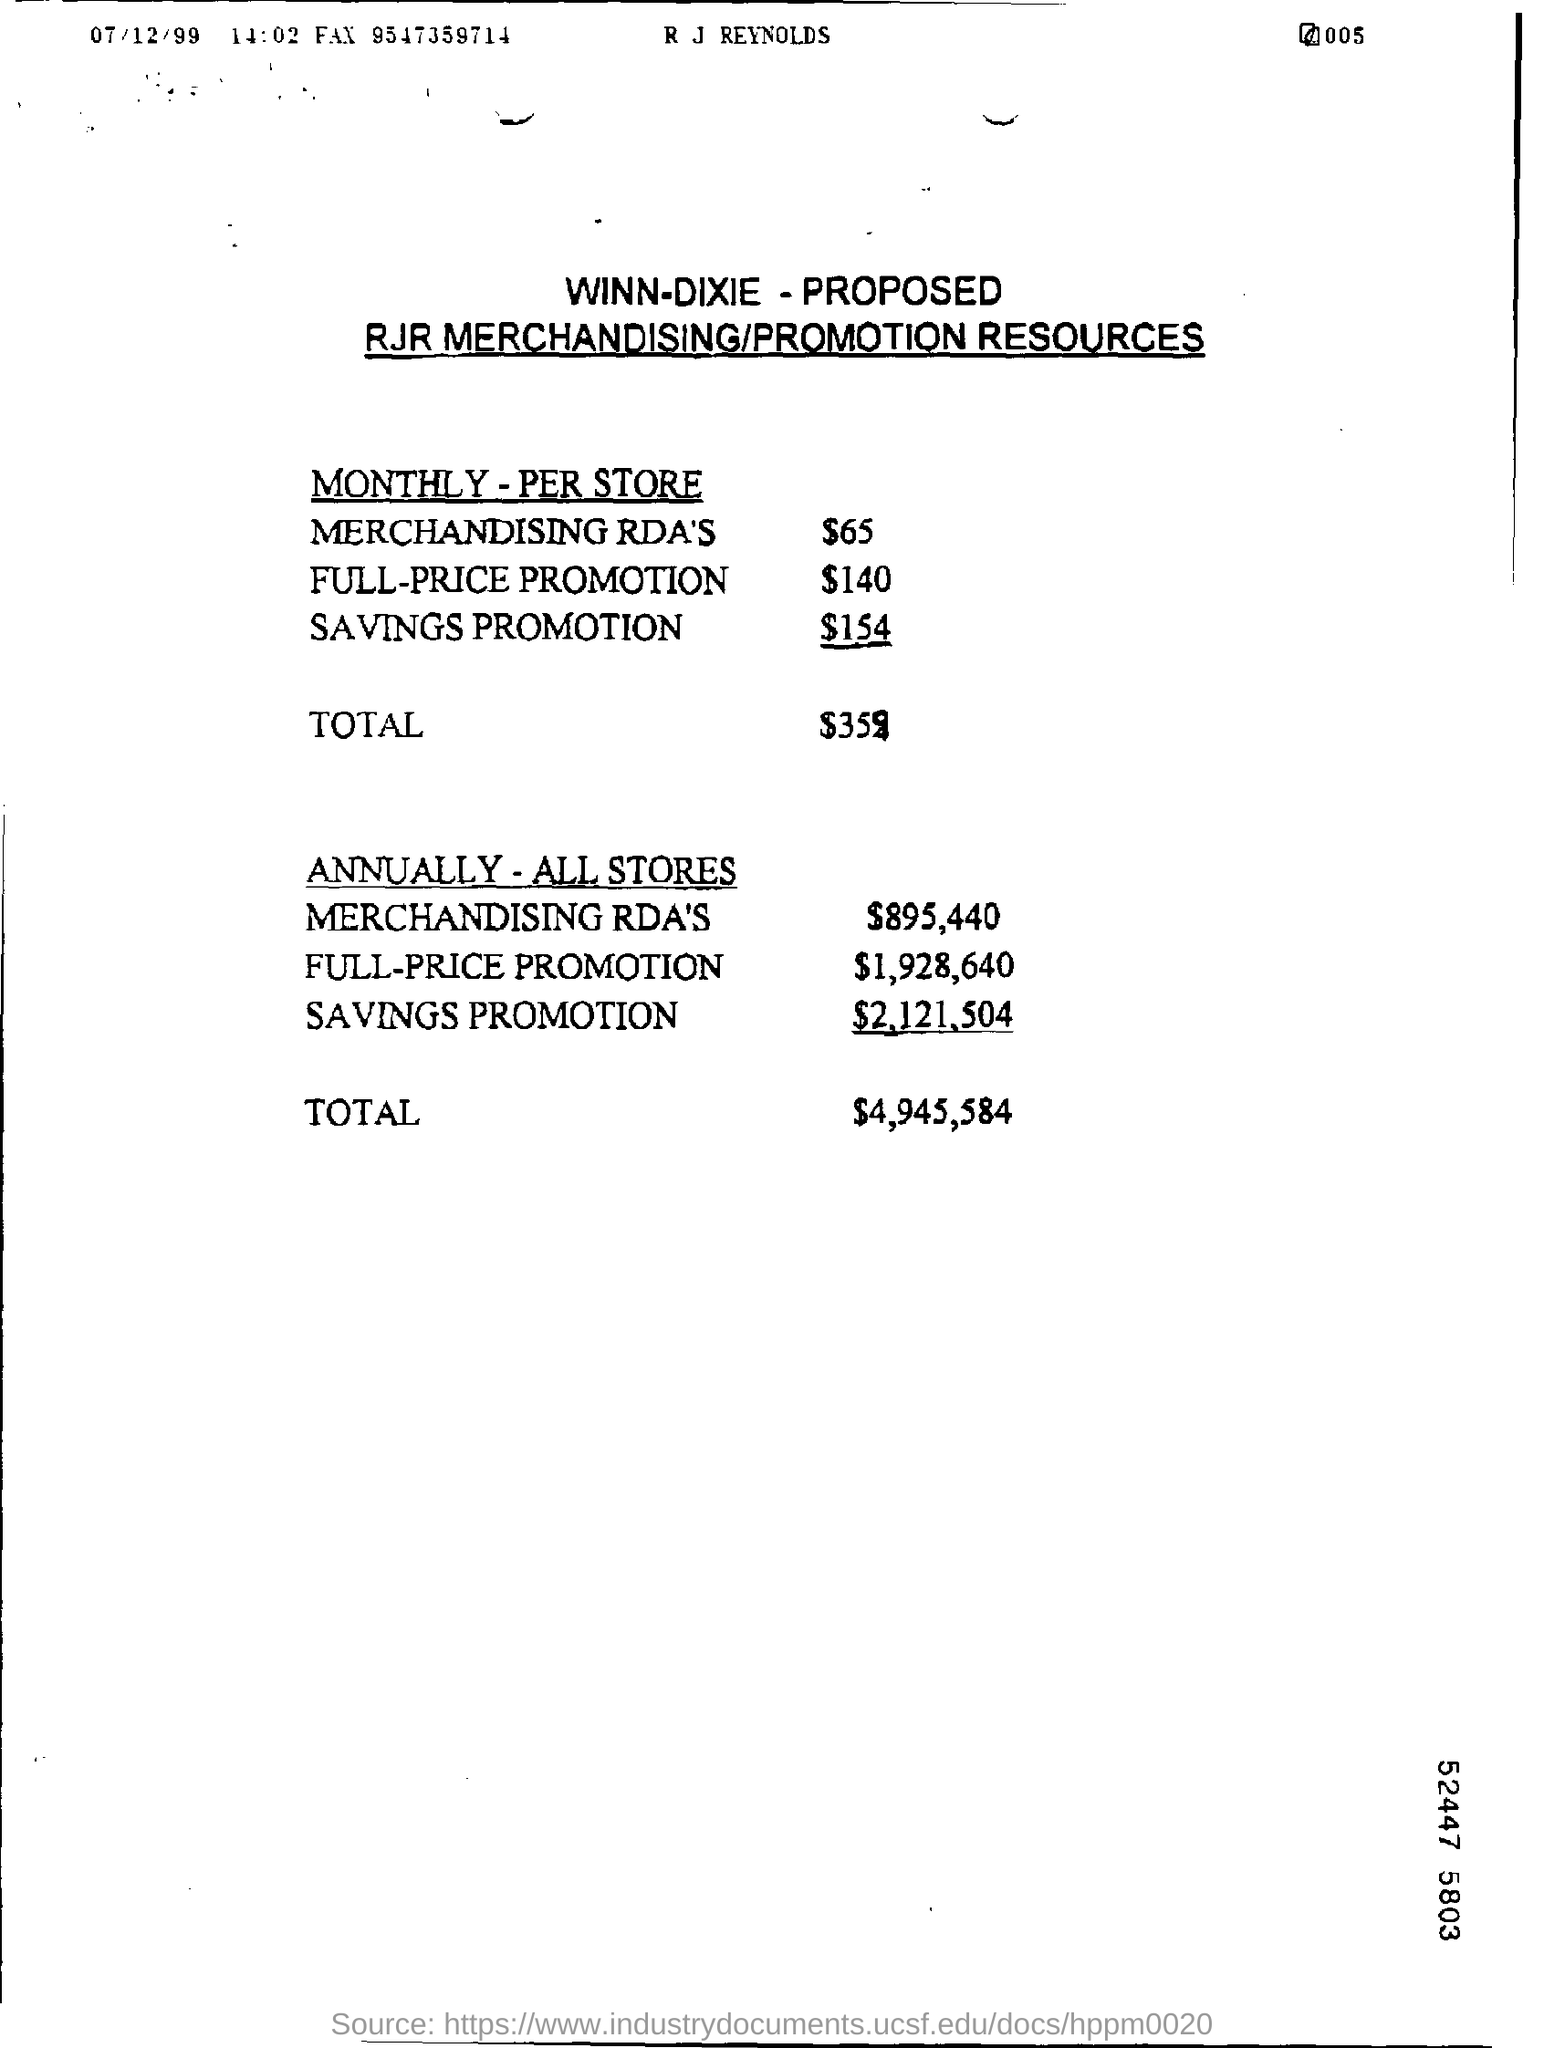What is the monthly amount of merchandising RDA' per store?
Your answer should be compact. $65. What is the total amount given for monthly per store?
Offer a very short reply. $359. What is the amount of merchandising RDA'S for all stores annually?
Your answer should be compact. $895, 440. What is the total amount for all the stores annually?
Your answer should be very brief. 4,945,584. What is the amount of full price promotion for all the stores annually?
Keep it short and to the point. $ 1,928,640. What is the amount of savings promotion for monthly per store?
Provide a short and direct response. $154. 